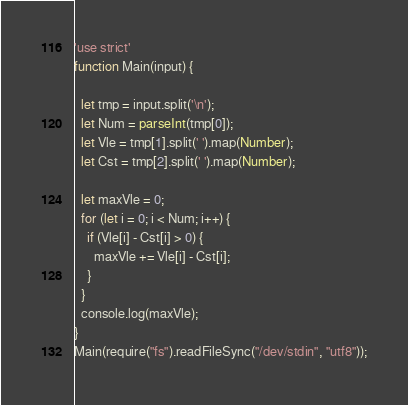Convert code to text. <code><loc_0><loc_0><loc_500><loc_500><_JavaScript_>'use strict'
function Main(input) {

  let tmp = input.split('\n');
  let Num = parseInt(tmp[0]);
  let Vle = tmp[1].split(' ').map(Number);
  let Cst = tmp[2].split(' ').map(Number);

  let maxVle = 0;
  for (let i = 0; i < Num; i++) {
    if (Vle[i] - Cst[i] > 0) {
      maxVle += Vle[i] - Cst[i];
    }
  }
  console.log(maxVle);
}
Main(require("fs").readFileSync("/dev/stdin", "utf8"));</code> 